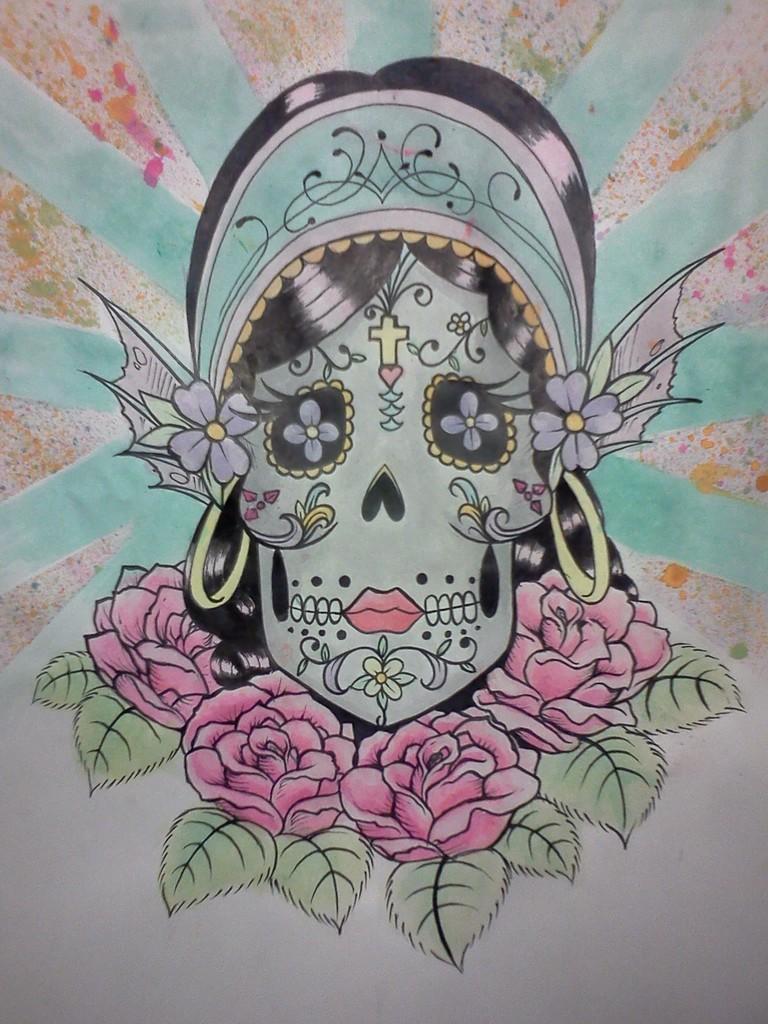Describe this image in one or two sentences. In this image I can see the poster which is green, black, red and white in color. I can see a person's face and few flowers. 